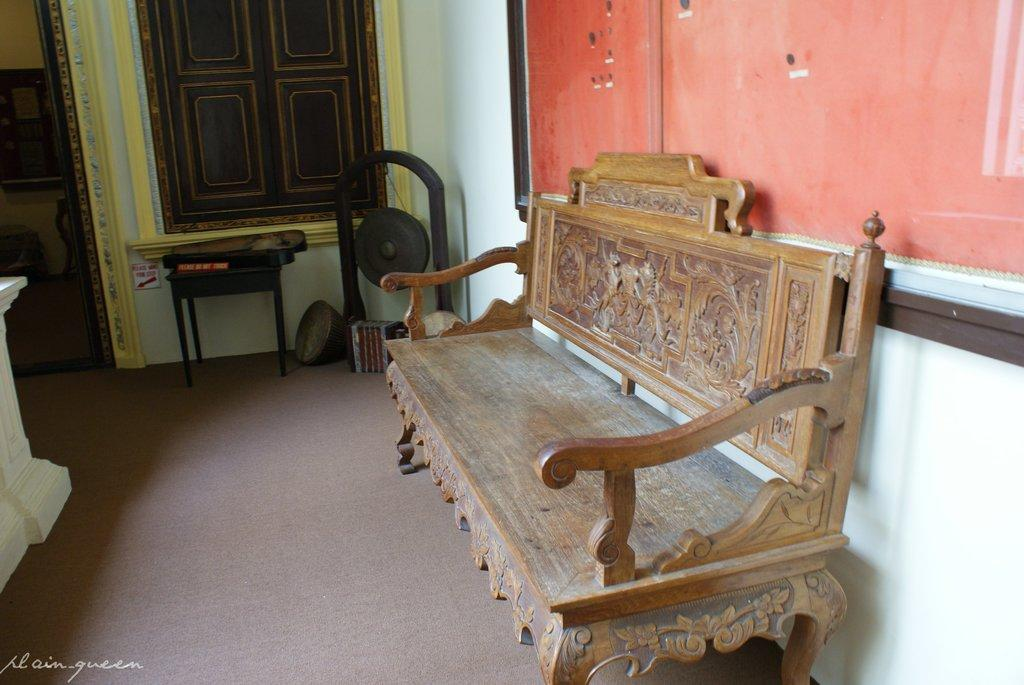What type of furniture is located on the left side of the image? There is a wooden sofa on the left side of the image. What can be seen in the background of the image? There is a table and a window in the background of the image. What is on the table in the image? There are objects on the table in the image. Can you see a feather floating near the wooden sofa in the image? There is no feather visible in the image. Is there a partner sitting on the wooden sofa in the image? The image does not show anyone sitting on the wooden sofa, so it cannot be determined if there is a partner present. 